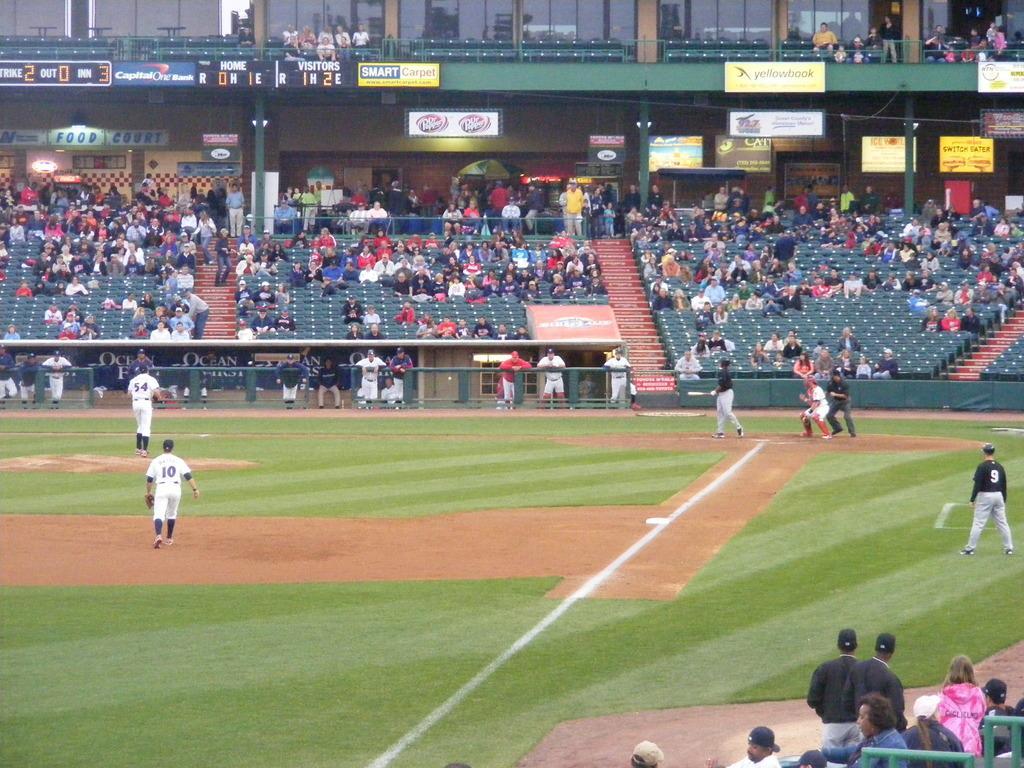Please provide a concise description of this image. In this picture, I can see a ground and players, Who are playing baseball game after that i can see the spectators, Who are sitting and standing. 